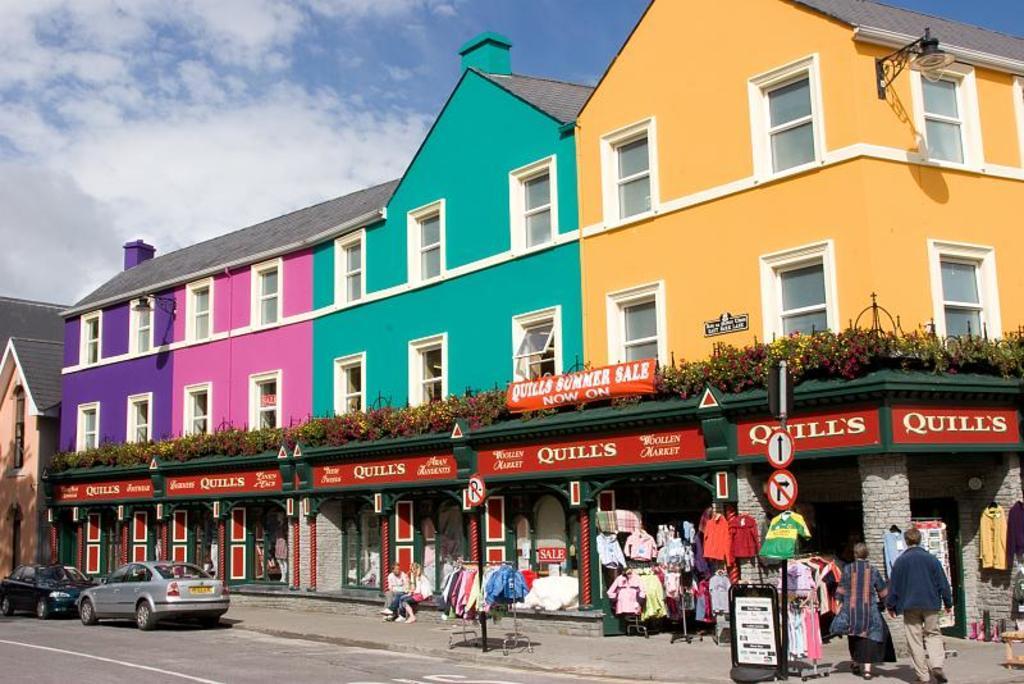Could you give a brief overview of what you see in this image? In the picture we can see a huge building with blue, pink, green and yellow in color with windows to it and under it we can see some shop, with clothes and two people are walking into it and near the building we can see two cars are parked and beside the building we can see a part of the other building with door and in the background we can see the sky with clouds. 